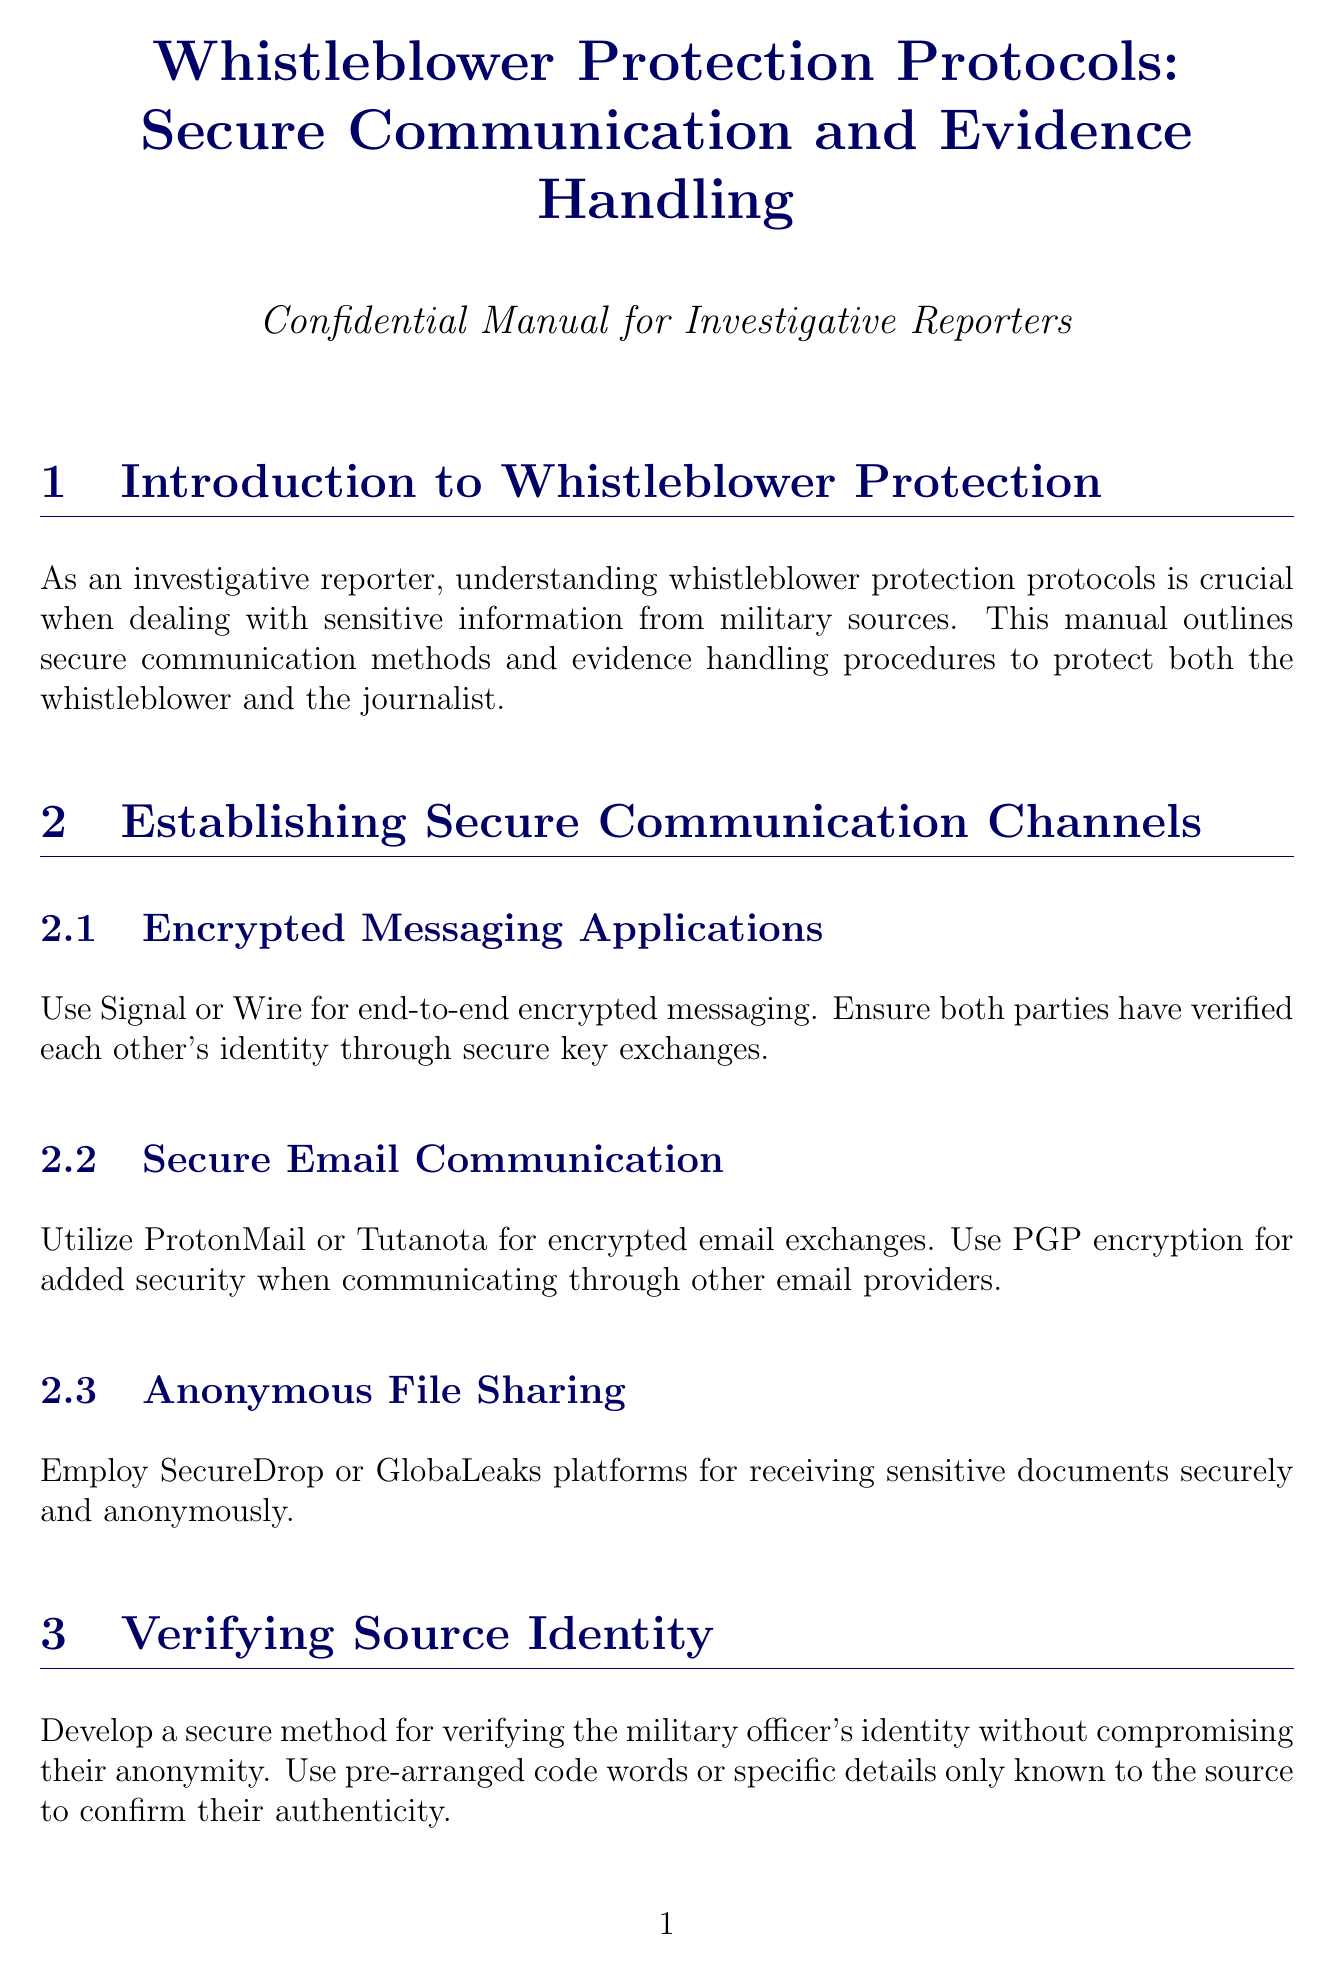What is the title of the manual? The title appears at the beginning of the document and states the purpose of the content.
Answer: Whistleblower Protection Protocols: Secure Communication and Evidence Handling Which applications are recommended for encrypted messaging? The section on secure communication channels specifies applications that ensure encrypted messaging.
Answer: Signal or Wire What is the purpose of maintaining a detailed log of evidence handling? This information is found in the section on Secure Evidence Handling and explains the importance of documentation.
Answer: Chain of Custody What should be used for secure destruction of digital evidence? The Emergency Protocols section provides guidance on how to securely dispose of digital files.
Answer: CCleaner What does the Whistleblower Protection Act relate to? This is mentioned in the Legal Considerations section, indicating its significance for whistleblowers.
Answer: Legal protections What are the two types of evidence handling mentioned? The Secure Evidence Handling section details distinct methods for managing different types of evidence.
Answer: Digital Evidence and Physical Documents What is essential for verifying the military officer's identity? The document describes a secure method for confirming identity in the context of anonymity.
Answer: Pre-arranged code words What should be used for anonymous file sharing? The section on establishing secure communication channels mentions platforms for safely sharing confidential documents.
Answer: SecureDrop or GlobaLeaks What is recommended for in-person meeting locations? The Operational Security section discusses the characteristics of locations for meeting sources safely.
Answer: Secure, neutral locations 